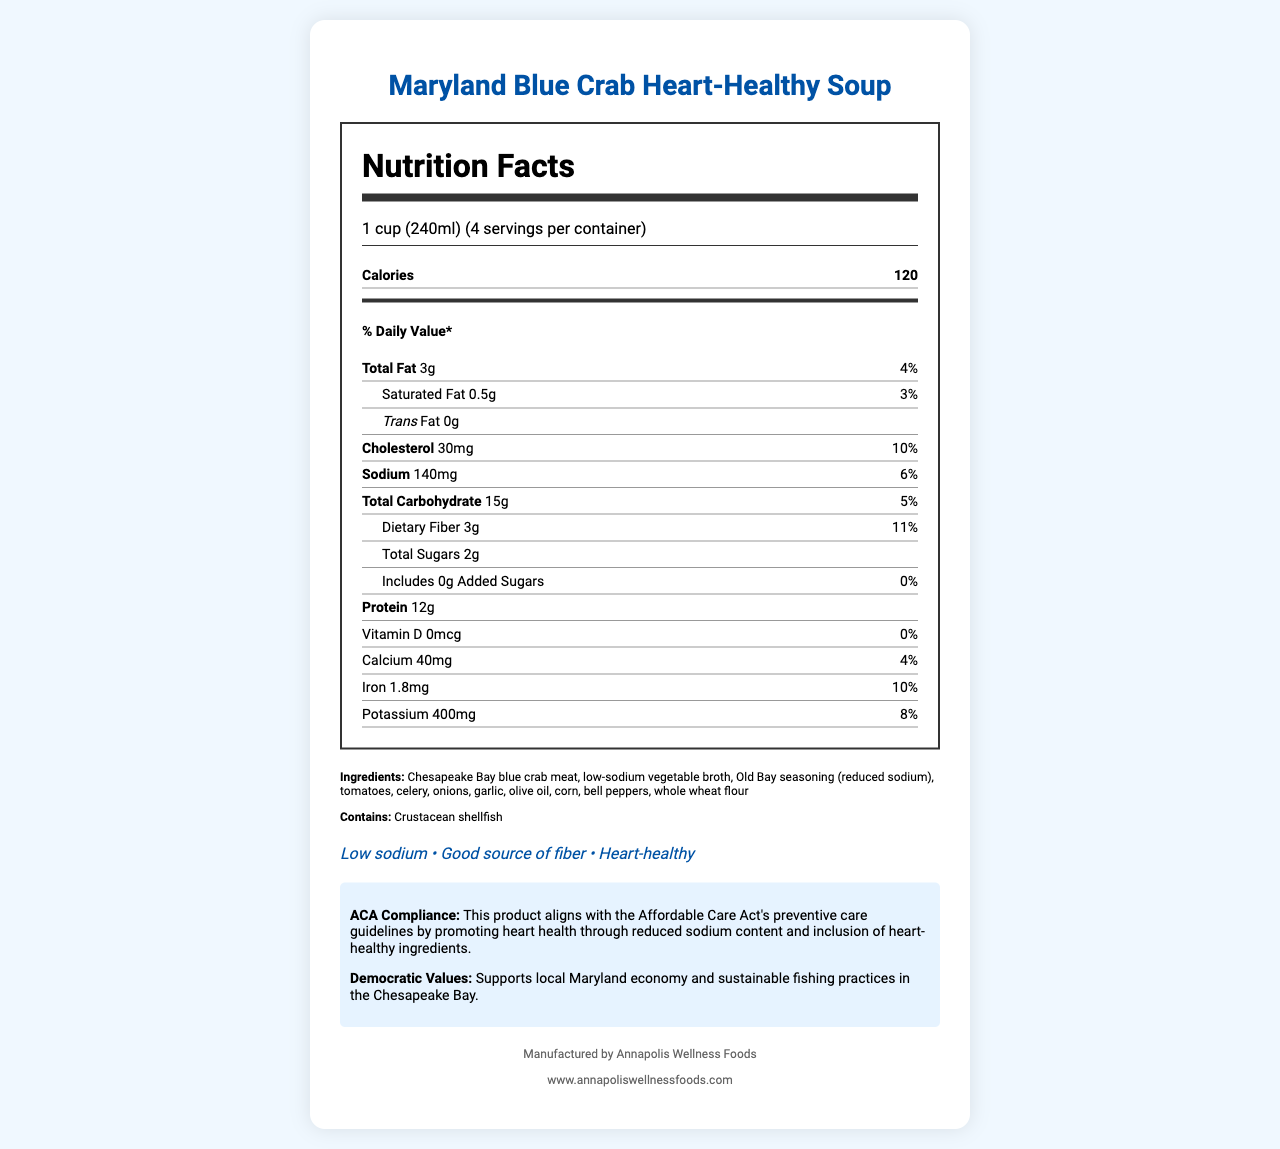what is the serving size? The serving size is clearly indicated in the document as "1 cup (240ml)."
Answer: 1 cup (240ml) how many calories are in one serving? The document states that there are 120 calories per serving.
Answer: 120 What is the percentage of the daily value of dietary fiber in one serving? The percentage of the daily value for dietary fiber in one serving is 11%, as listed in the document.
Answer: 11% What is the amount of sodium per serving? The document specifies that the amount of sodium per serving is 140mg.
Answer: 140mg How much protein is in one serving? The protein content per serving is clearly indicated as 12g in the document.
Answer: 12g Which of the following ingredients is present in the soup? A. Beef B. Chicken C. Chesapeake Bay blue crab meat The document lists the ingredients, and Chesapeake Bay blue crab meat is one of them.
Answer: C What company manufactures the Maryland Blue Crab Heart-Healthy Soup? A. Annapolis Wellness Foods B. Baltimore Best C. Chesapeake Cuisine The document states that the manufacturer is Annapolis Wellness Foods.
Answer: A Is this soup considered low sodium? The document lists "Low sodium" as one of the health claims.
Answer: Yes Does this soup contain any added sugars? The document specifies that the amount of added sugars is 0g, indicating no added sugars.
Answer: No Summarize the main features and health benefits of the Maryland Blue Crab Heart-Healthy Soup. The document highlights the soup's nutritional information, ACA compliance, health claims, and the values it supports, providing a comprehensive overview of its benefits.
Answer: The Maryland Blue Crab Heart-Healthy Soup is a low-sodium, heart-healthy option promoting the Affordable Care Act's preventive care guidelines by supporting heart health. It contains 120 calories per serving, with low amounts of total fat (3g), saturated fat (0.5g), and cholesterol (30mg). It provides significant dietary fiber (11% daily value) and protein (12g), with only 140mg of sodium. The soup uses local Chesapeake Bay blue crab meat and supports sustainable fishing practices, aligning with Democratic values of supporting local economies. Can the soup help in meeting the daily requirement of calcium? The document shows that the soup's calcium content is 40mg, which is 4% of the daily value, indicating a minor contribution to the daily calcium requirement.
Answer: Not significantly. What does the ACA compliance statement emphasize about the soup? The ACA compliance statement mentions that the product aligns with the Affordable Care Act's preventive care guidelines by promoting heart health with reduced sodium and heart-healthy ingredients.
Answer: It emphasizes that the soup promotes heart health through reduced sodium content and the inclusion of heart-healthy ingredients. How many servings are in a container of the Maryland Blue Crab Heart-Healthy Soup? The document states there are 4 servings per container.
Answer: 4 servings What are the allergens present in the soup? The document lists crustacean shellfish as the allergen.
Answer: Crustacean shellfish Which nutrient has the highest percentage of daily value per serving? A. Vitamin D B. Potassium C. Dietary Fiber The document shows that dietary fiber has the highest percentage of daily value at 11%.
Answer: C How does the product support Democratic values? The document mentions that the product supports Democratic values by boosting the local economy and following sustainable practices.
Answer: By supporting the local Maryland economy and sustainable fishing practices in the Chesapeake Bay. What is the year of inception of Annapolis Wellness Foods? The document does not provide any information regarding the year of inception of Annapolis Wellness Foods.
Answer: Cannot be determined 